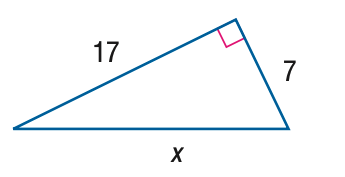Answer the mathemtical geometry problem and directly provide the correct option letter.
Question: Find x.
Choices: A: 4 \sqrt { 15 } B: 13 \sqrt { 2 } C: 13 \sqrt { 3 } D: 8 \sqrt { 15 } B 